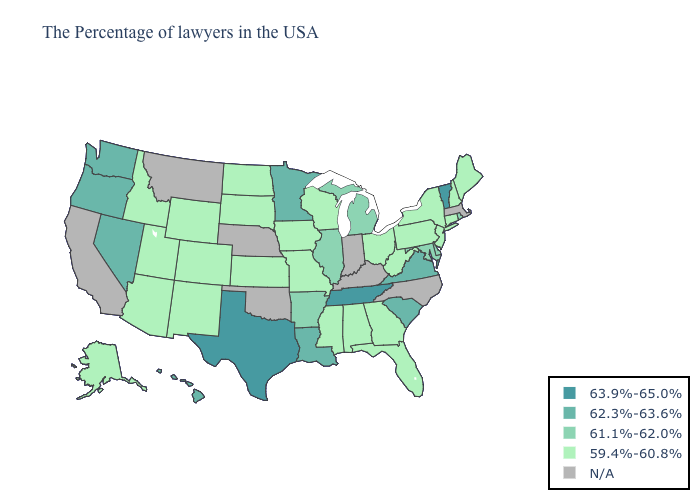Is the legend a continuous bar?
Give a very brief answer. No. Which states hav the highest value in the MidWest?
Quick response, please. Minnesota. Name the states that have a value in the range 63.9%-65.0%?
Concise answer only. Vermont, Tennessee, Texas. Among the states that border Indiana , does Michigan have the lowest value?
Write a very short answer. No. Name the states that have a value in the range 61.1%-62.0%?
Quick response, please. Rhode Island, Delaware, Maryland, Michigan, Illinois, Arkansas. What is the value of Florida?
Write a very short answer. 59.4%-60.8%. Name the states that have a value in the range 62.3%-63.6%?
Concise answer only. Virginia, South Carolina, Louisiana, Minnesota, Nevada, Washington, Oregon, Hawaii. Which states have the lowest value in the USA?
Be succinct. Maine, New Hampshire, Connecticut, New York, New Jersey, Pennsylvania, West Virginia, Ohio, Florida, Georgia, Alabama, Wisconsin, Mississippi, Missouri, Iowa, Kansas, South Dakota, North Dakota, Wyoming, Colorado, New Mexico, Utah, Arizona, Idaho, Alaska. What is the highest value in states that border New Hampshire?
Write a very short answer. 63.9%-65.0%. What is the highest value in the USA?
Be succinct. 63.9%-65.0%. What is the value of Montana?
Be succinct. N/A. What is the value of Maryland?
Write a very short answer. 61.1%-62.0%. What is the highest value in the USA?
Be succinct. 63.9%-65.0%. What is the value of Georgia?
Answer briefly. 59.4%-60.8%. Among the states that border Missouri , which have the highest value?
Answer briefly. Tennessee. 